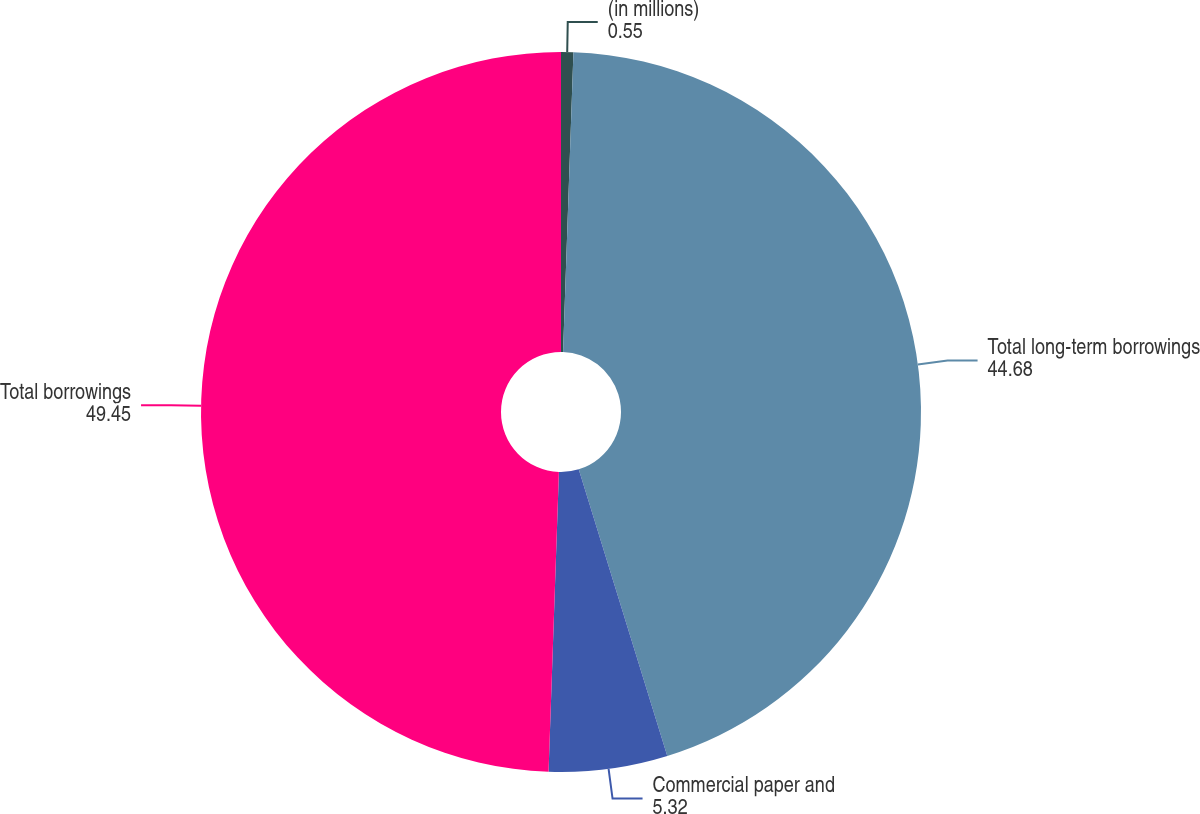Convert chart. <chart><loc_0><loc_0><loc_500><loc_500><pie_chart><fcel>(in millions)<fcel>Total long-term borrowings<fcel>Commercial paper and<fcel>Total borrowings<nl><fcel>0.55%<fcel>44.68%<fcel>5.32%<fcel>49.45%<nl></chart> 